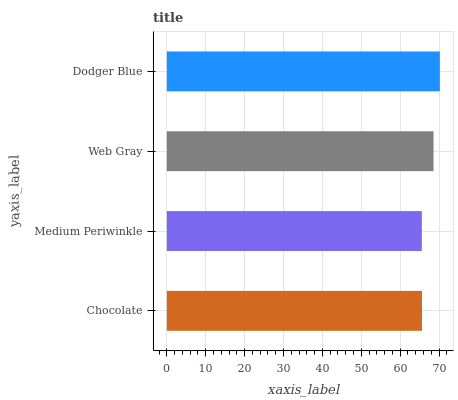Is Medium Periwinkle the minimum?
Answer yes or no. Yes. Is Dodger Blue the maximum?
Answer yes or no. Yes. Is Web Gray the minimum?
Answer yes or no. No. Is Web Gray the maximum?
Answer yes or no. No. Is Web Gray greater than Medium Periwinkle?
Answer yes or no. Yes. Is Medium Periwinkle less than Web Gray?
Answer yes or no. Yes. Is Medium Periwinkle greater than Web Gray?
Answer yes or no. No. Is Web Gray less than Medium Periwinkle?
Answer yes or no. No. Is Web Gray the high median?
Answer yes or no. Yes. Is Chocolate the low median?
Answer yes or no. Yes. Is Medium Periwinkle the high median?
Answer yes or no. No. Is Web Gray the low median?
Answer yes or no. No. 